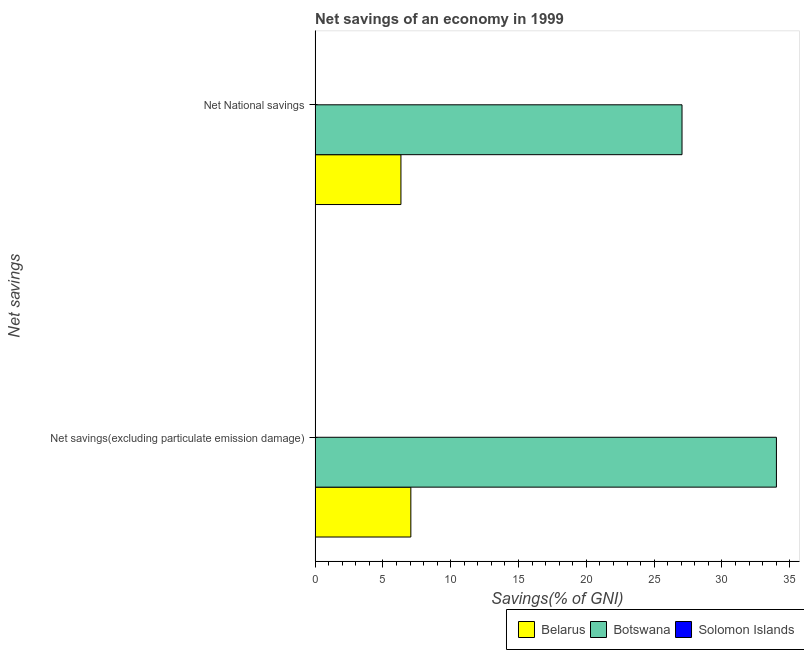How many different coloured bars are there?
Your response must be concise. 2. How many groups of bars are there?
Ensure brevity in your answer.  2. What is the label of the 2nd group of bars from the top?
Ensure brevity in your answer.  Net savings(excluding particulate emission damage). What is the net national savings in Solomon Islands?
Offer a very short reply. 0. Across all countries, what is the maximum net national savings?
Your answer should be compact. 27.05. In which country was the net national savings maximum?
Provide a short and direct response. Botswana. What is the total net savings(excluding particulate emission damage) in the graph?
Provide a short and direct response. 41.07. What is the difference between the net national savings in Botswana and that in Belarus?
Make the answer very short. 20.73. What is the difference between the net national savings in Solomon Islands and the net savings(excluding particulate emission damage) in Botswana?
Keep it short and to the point. -34.02. What is the average net savings(excluding particulate emission damage) per country?
Offer a terse response. 13.69. What is the difference between the net national savings and net savings(excluding particulate emission damage) in Botswana?
Your answer should be compact. -6.96. In how many countries, is the net national savings greater than 20 %?
Provide a succinct answer. 1. What is the ratio of the net national savings in Botswana to that in Belarus?
Keep it short and to the point. 4.27. Is the net national savings in Botswana less than that in Belarus?
Your answer should be compact. No. How many bars are there?
Your response must be concise. 4. Are the values on the major ticks of X-axis written in scientific E-notation?
Your answer should be very brief. No. Does the graph contain grids?
Give a very brief answer. No. Where does the legend appear in the graph?
Ensure brevity in your answer.  Bottom right. How many legend labels are there?
Keep it short and to the point. 3. How are the legend labels stacked?
Offer a very short reply. Horizontal. What is the title of the graph?
Your answer should be very brief. Net savings of an economy in 1999. Does "European Union" appear as one of the legend labels in the graph?
Offer a very short reply. No. What is the label or title of the X-axis?
Your answer should be very brief. Savings(% of GNI). What is the label or title of the Y-axis?
Provide a succinct answer. Net savings. What is the Savings(% of GNI) in Belarus in Net savings(excluding particulate emission damage)?
Ensure brevity in your answer.  7.06. What is the Savings(% of GNI) in Botswana in Net savings(excluding particulate emission damage)?
Make the answer very short. 34.02. What is the Savings(% of GNI) in Belarus in Net National savings?
Provide a short and direct response. 6.33. What is the Savings(% of GNI) of Botswana in Net National savings?
Your response must be concise. 27.05. Across all Net savings, what is the maximum Savings(% of GNI) of Belarus?
Ensure brevity in your answer.  7.06. Across all Net savings, what is the maximum Savings(% of GNI) of Botswana?
Make the answer very short. 34.02. Across all Net savings, what is the minimum Savings(% of GNI) of Belarus?
Provide a short and direct response. 6.33. Across all Net savings, what is the minimum Savings(% of GNI) of Botswana?
Keep it short and to the point. 27.05. What is the total Savings(% of GNI) of Belarus in the graph?
Ensure brevity in your answer.  13.39. What is the total Savings(% of GNI) of Botswana in the graph?
Provide a short and direct response. 61.07. What is the difference between the Savings(% of GNI) in Belarus in Net savings(excluding particulate emission damage) and that in Net National savings?
Keep it short and to the point. 0.73. What is the difference between the Savings(% of GNI) in Botswana in Net savings(excluding particulate emission damage) and that in Net National savings?
Your answer should be very brief. 6.96. What is the difference between the Savings(% of GNI) in Belarus in Net savings(excluding particulate emission damage) and the Savings(% of GNI) in Botswana in Net National savings?
Keep it short and to the point. -19.99. What is the average Savings(% of GNI) in Belarus per Net savings?
Provide a succinct answer. 6.69. What is the average Savings(% of GNI) of Botswana per Net savings?
Keep it short and to the point. 30.53. What is the average Savings(% of GNI) in Solomon Islands per Net savings?
Provide a succinct answer. 0. What is the difference between the Savings(% of GNI) of Belarus and Savings(% of GNI) of Botswana in Net savings(excluding particulate emission damage)?
Give a very brief answer. -26.96. What is the difference between the Savings(% of GNI) of Belarus and Savings(% of GNI) of Botswana in Net National savings?
Your answer should be very brief. -20.73. What is the ratio of the Savings(% of GNI) of Belarus in Net savings(excluding particulate emission damage) to that in Net National savings?
Make the answer very short. 1.12. What is the ratio of the Savings(% of GNI) in Botswana in Net savings(excluding particulate emission damage) to that in Net National savings?
Provide a succinct answer. 1.26. What is the difference between the highest and the second highest Savings(% of GNI) in Belarus?
Make the answer very short. 0.73. What is the difference between the highest and the second highest Savings(% of GNI) in Botswana?
Keep it short and to the point. 6.96. What is the difference between the highest and the lowest Savings(% of GNI) of Belarus?
Offer a terse response. 0.73. What is the difference between the highest and the lowest Savings(% of GNI) in Botswana?
Ensure brevity in your answer.  6.96. 